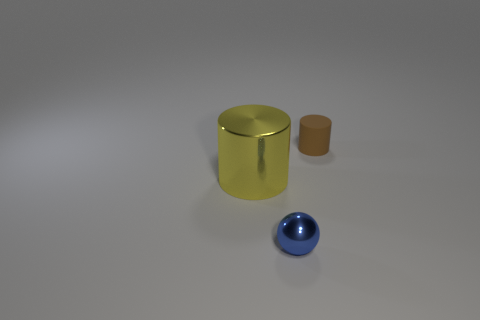Is there anything else that has the same material as the small cylinder?
Offer a terse response. No. What number of other objects are the same shape as the large yellow metal thing?
Keep it short and to the point. 1. How many yellow things are either metallic cylinders or big matte cylinders?
Your response must be concise. 1. The small blue thing that is made of the same material as the yellow thing is what shape?
Offer a terse response. Sphere. What is the color of the thing that is both behind the shiny ball and left of the tiny brown rubber thing?
Make the answer very short. Yellow. What size is the cylinder that is right of the thing on the left side of the shiny sphere?
Provide a succinct answer. Small. Are there the same number of small things on the left side of the tiny rubber thing and tiny blue metallic things?
Ensure brevity in your answer.  Yes. How many big green objects are there?
Provide a short and direct response. 0. There is a thing that is in front of the matte cylinder and to the right of the yellow shiny cylinder; what shape is it?
Your answer should be compact. Sphere. Is there a cylinder made of the same material as the sphere?
Offer a very short reply. Yes. 